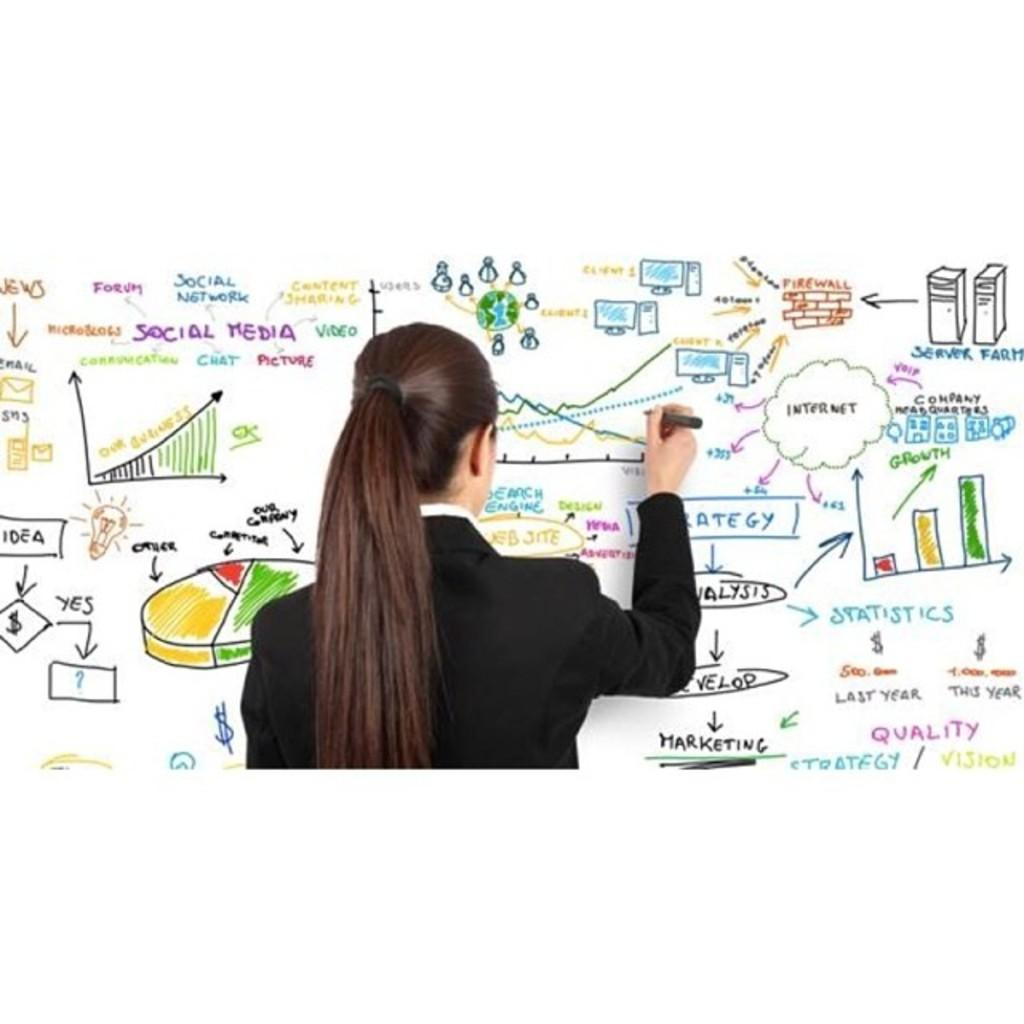Who is the main subject in the image? There is a woman in the image. What is the woman doing in the image? The woman is writing on a board. What is the woman wearing in the image? The woman is wearing a black coat. What is the woman holding in the image? The woman is holding a marker pen. What can be seen on the board in the image? There are drawings and a flow chart on the board. Is the woman celebrating her birthday in the image? There is no indication in the image that the woman is celebrating her birthday. Is the woman in a quiet environment in the image? The image does not provide information about the noise level in the environment. 